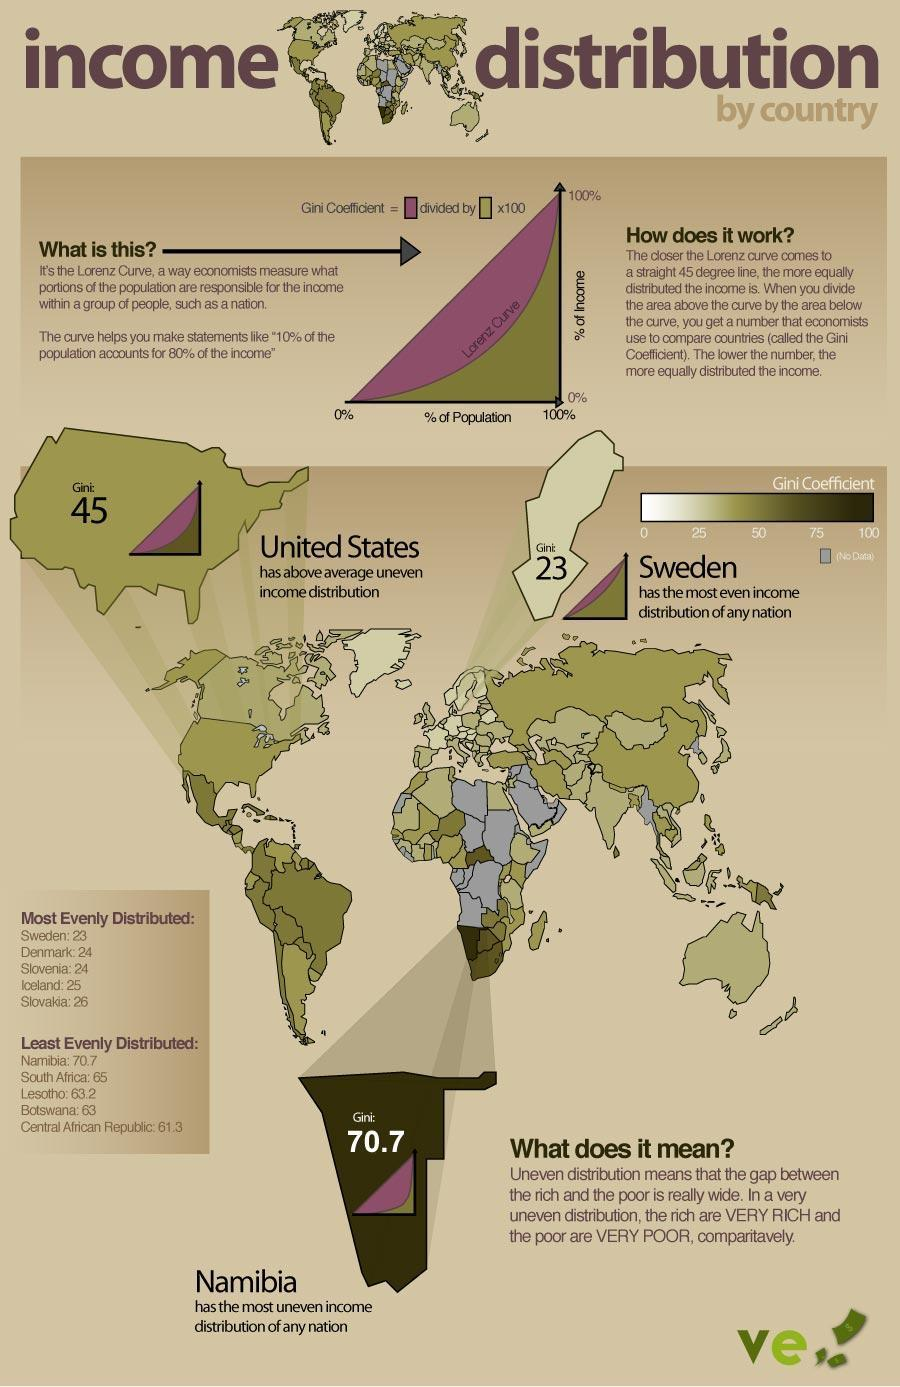Which two countries have a Gini score of 24?
Answer the question with a short phrase. Denmark, Slovenia Which country has the highest Gini score? Namibia 